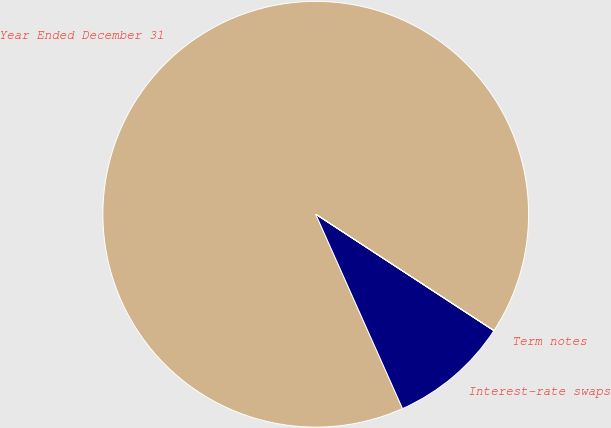Convert chart to OTSL. <chart><loc_0><loc_0><loc_500><loc_500><pie_chart><fcel>Year Ended December 31<fcel>Interest-rate swaps<fcel>Term notes<nl><fcel>90.89%<fcel>9.1%<fcel>0.01%<nl></chart> 